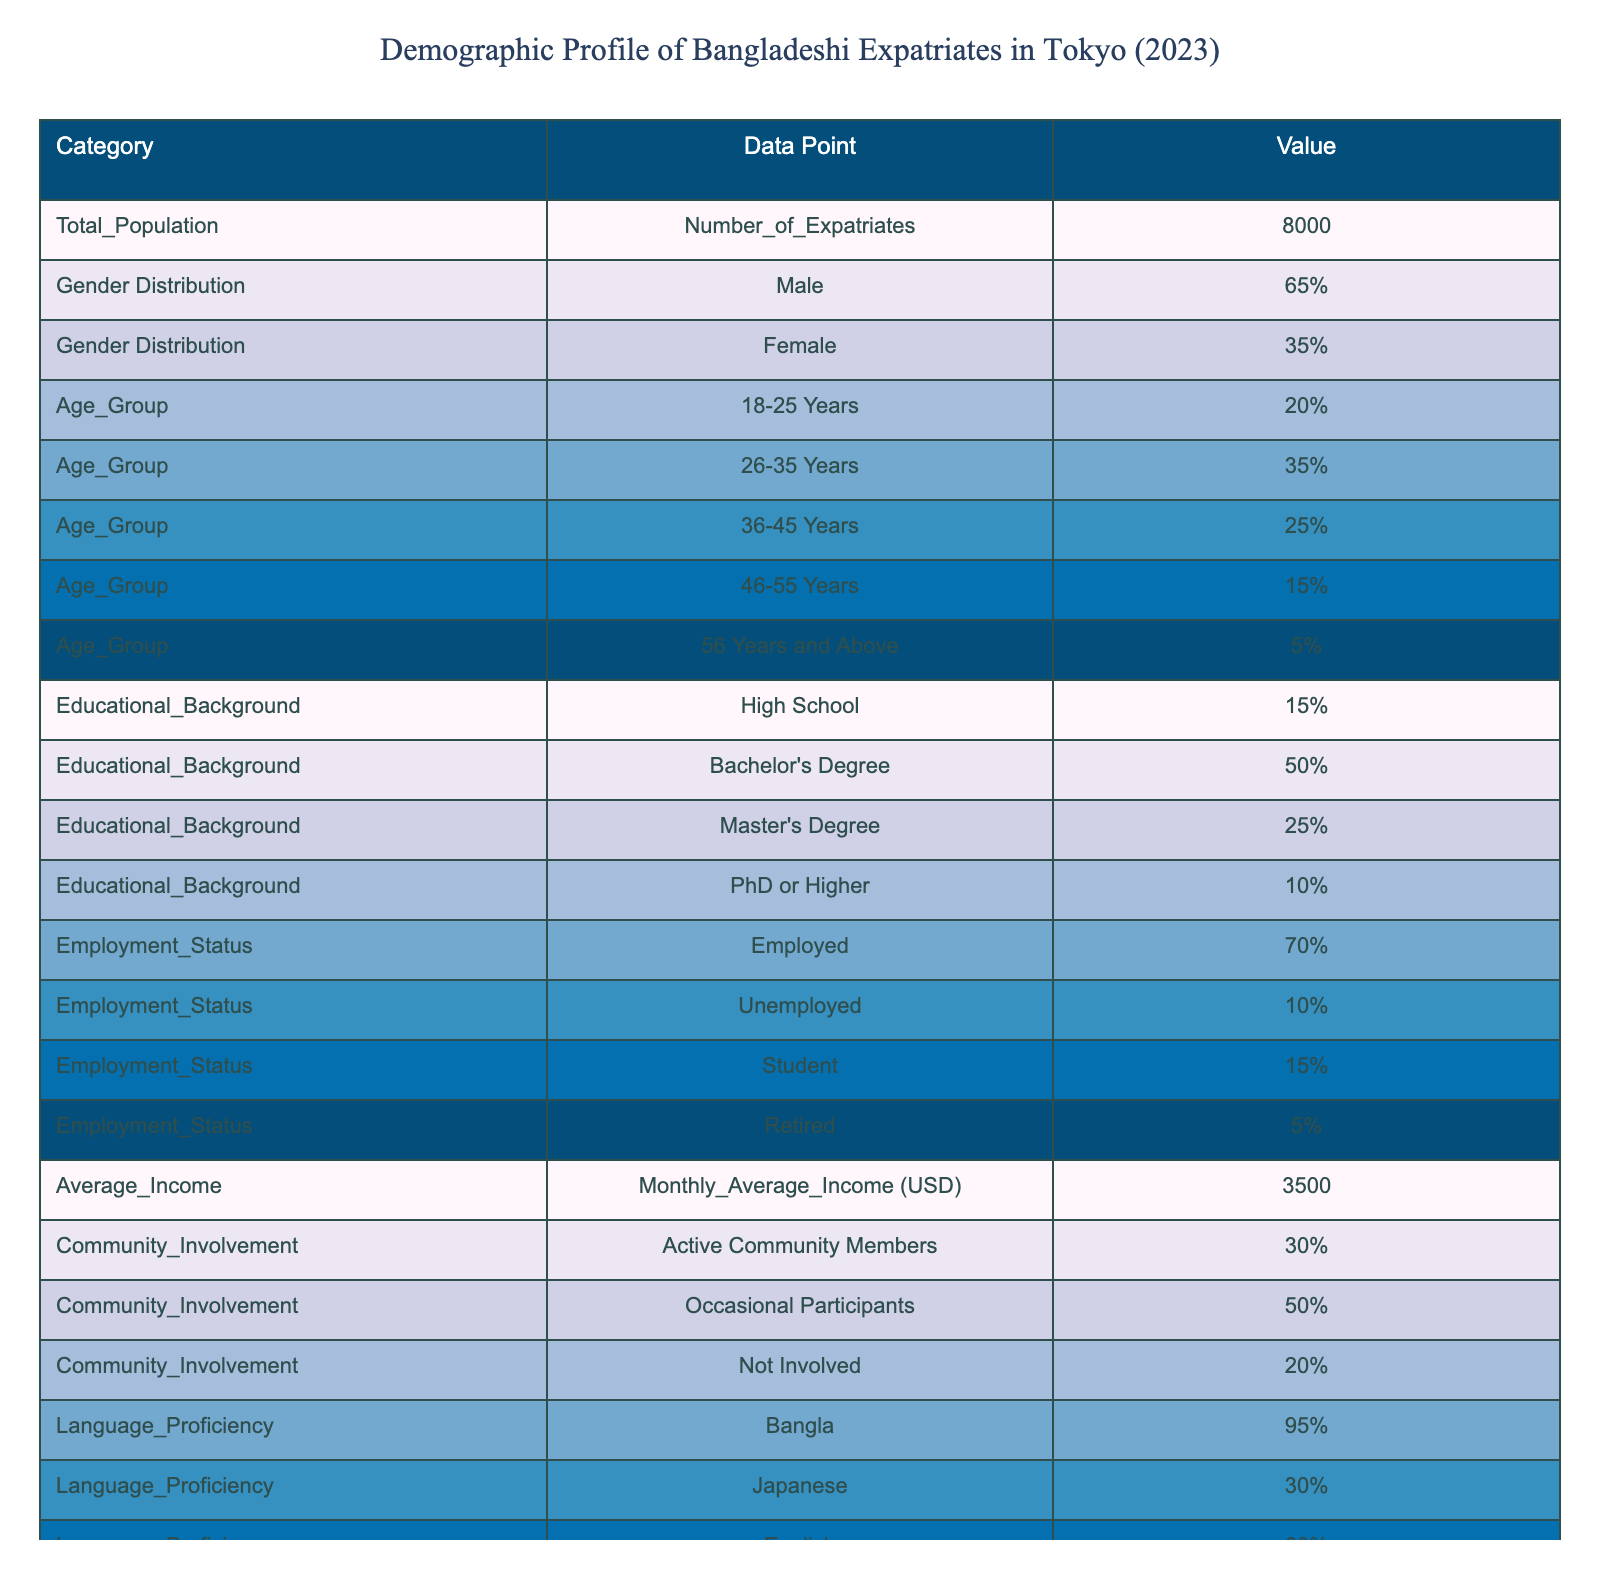What is the total number of Bangladeshi expatriates in Tokyo? According to the data in the table, the total number of expatriates is listed under the "Total Population" category as "Number of Expatriates," which is 8000.
Answer: 8000 What percentage of Bangladeshi expatriates are employed? The employment status section of the table indicates that 70% of Bangladeshi expatriates are employed, which is a clear percentage provided directly in the table.
Answer: 70% How many expatriates are in the age group of 36-45 years? To find the number of expatriates in the age group of 36-45 years, we take the total population (8000) and multiply it by the percentage in that age group (25%). Therefore, 8000 * 0.25 = 2000 expatriates.
Answer: 2000 Is the majority of Bangladeshi expatriates in Tokyo male? The gender distribution shows that 65% of the expatriates are male, which is greater than 50%. Therefore, we can conclude that the majority are indeed male.
Answer: Yes What is the average monthly income of Bangladeshi expatriates in Tokyo? The average income is specified in the "Average Income" section of the table as "Monthly Average Income (USD)," which is 3500 USD.
Answer: 3500 USD What percentage of the Bangladeshi expatriate community is involved in community activities? From the "Community Involvement" category, 30% are active community members, 50% are occasional participants, and 20% are not involved, showing that overall involvement combined (active + occasional) is 30% + 50% = 80%.
Answer: 80% What is the percentage of Bangladeshi expatriates who speak English? The language proficiency section of the table states that 60% of the expatriates are proficient in English, which is directly provided.
Answer: 60% How many expatriates are unemployed if the unemployment rate is 10%? The unemployment statistics reveal that 10% of the total population (8000) are unemployed. Therefore, 8000 * 0.10 = 800 expatriates are unemployed.
Answer: 800 What is the proportion of expatriates with a master's degree compared to those with a bachelor's degree? From the educational background, 25% have a master's degree, and 50% have a bachelor's degree. To compare them, we can create a ratio: 25% / 50% = 0.5. This means there is one master's degree holder for every two bachelor's degree holders.
Answer: 0.5 (1:2 ratio) 